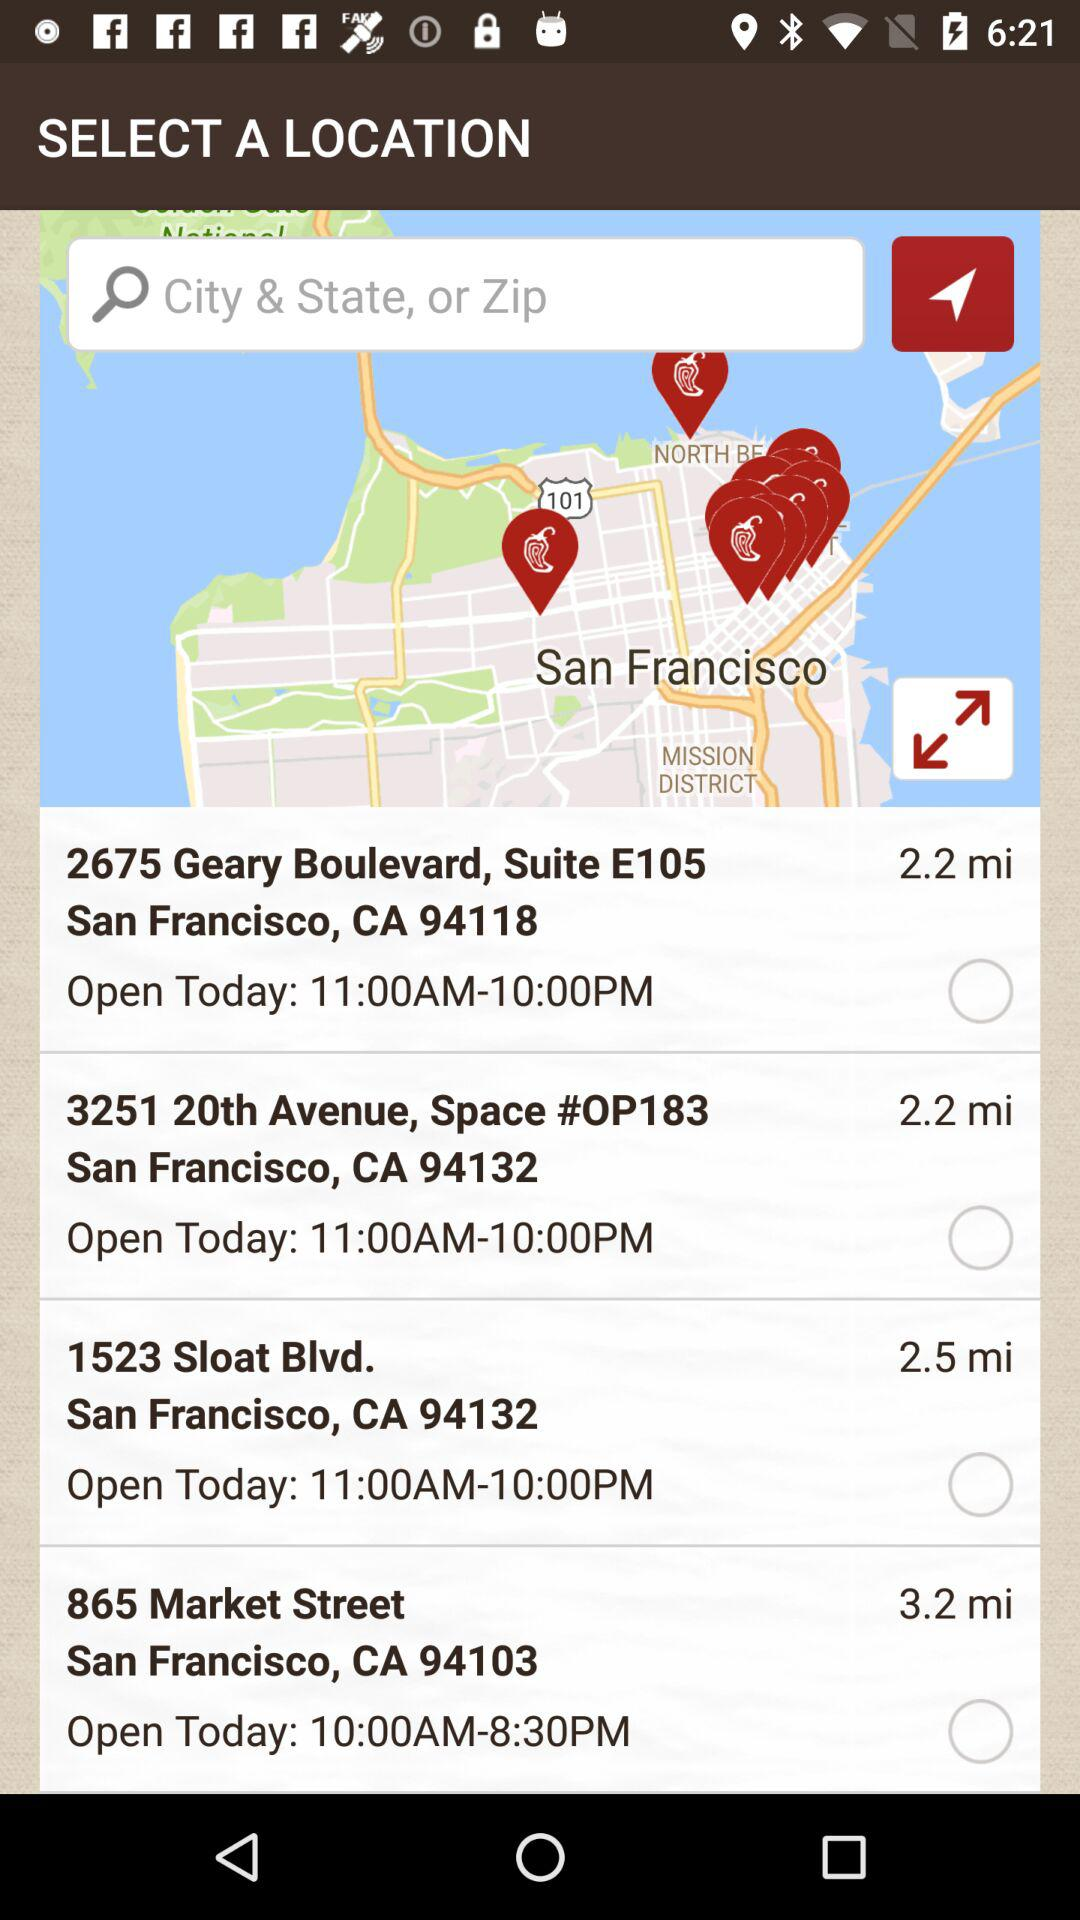How many miles is the closest location to the user?
Answer the question using a single word or phrase. 2.2 mi 